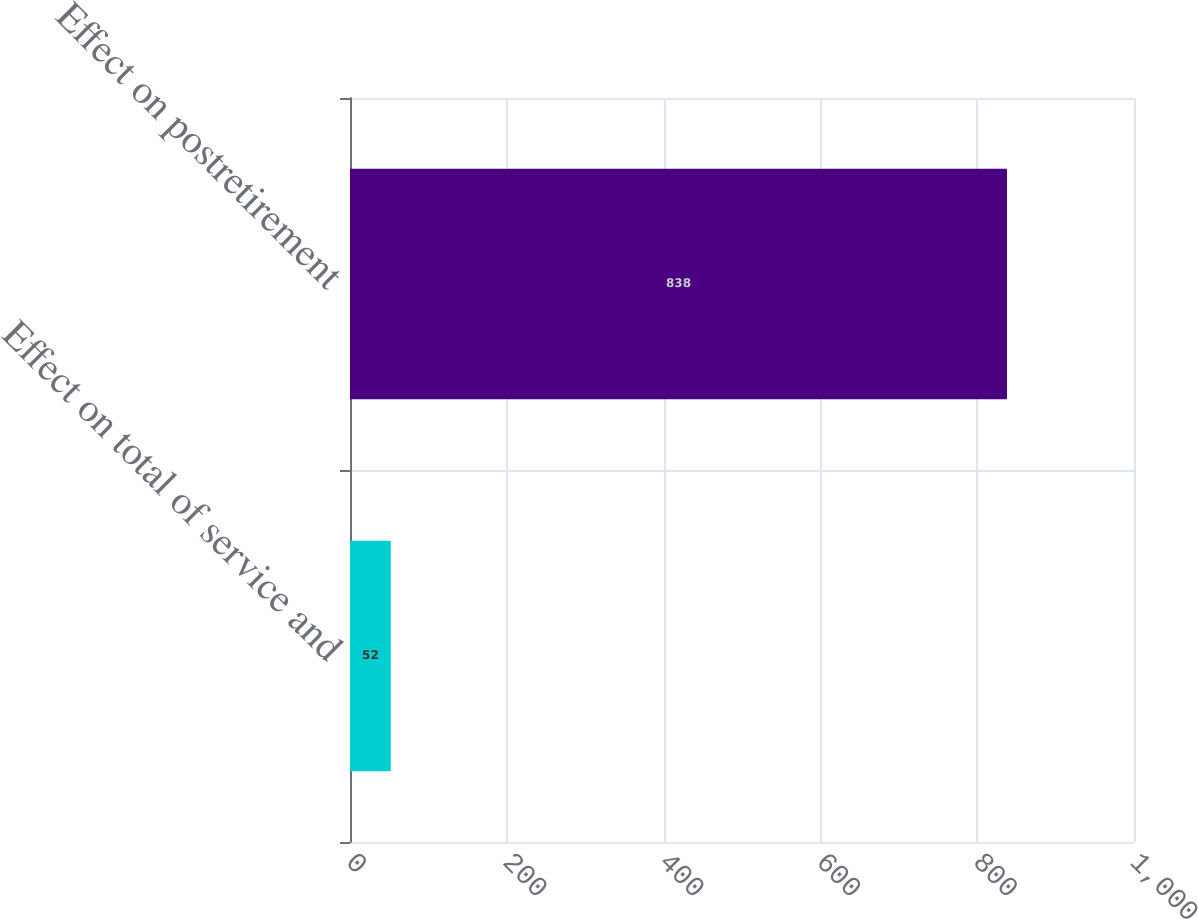Convert chart. <chart><loc_0><loc_0><loc_500><loc_500><bar_chart><fcel>Effect on total of service and<fcel>Effect on postretirement<nl><fcel>52<fcel>838<nl></chart> 